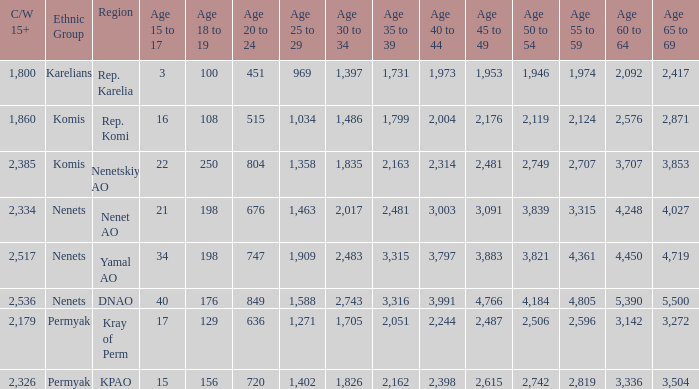With a 35 to 39 greater than 3,315 what is the 45 to 49? 4766.0. 